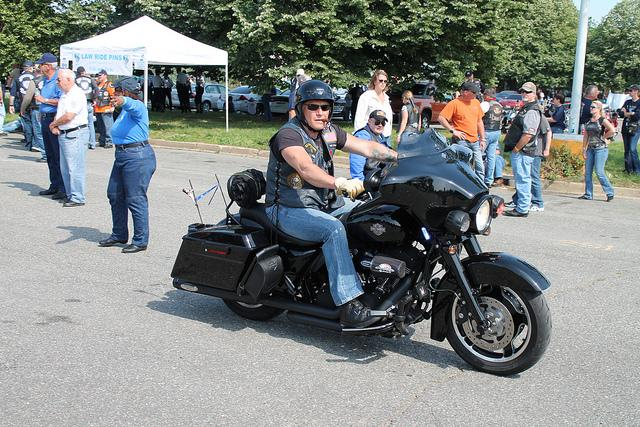What is the man with the helmet on wearing? helmet 